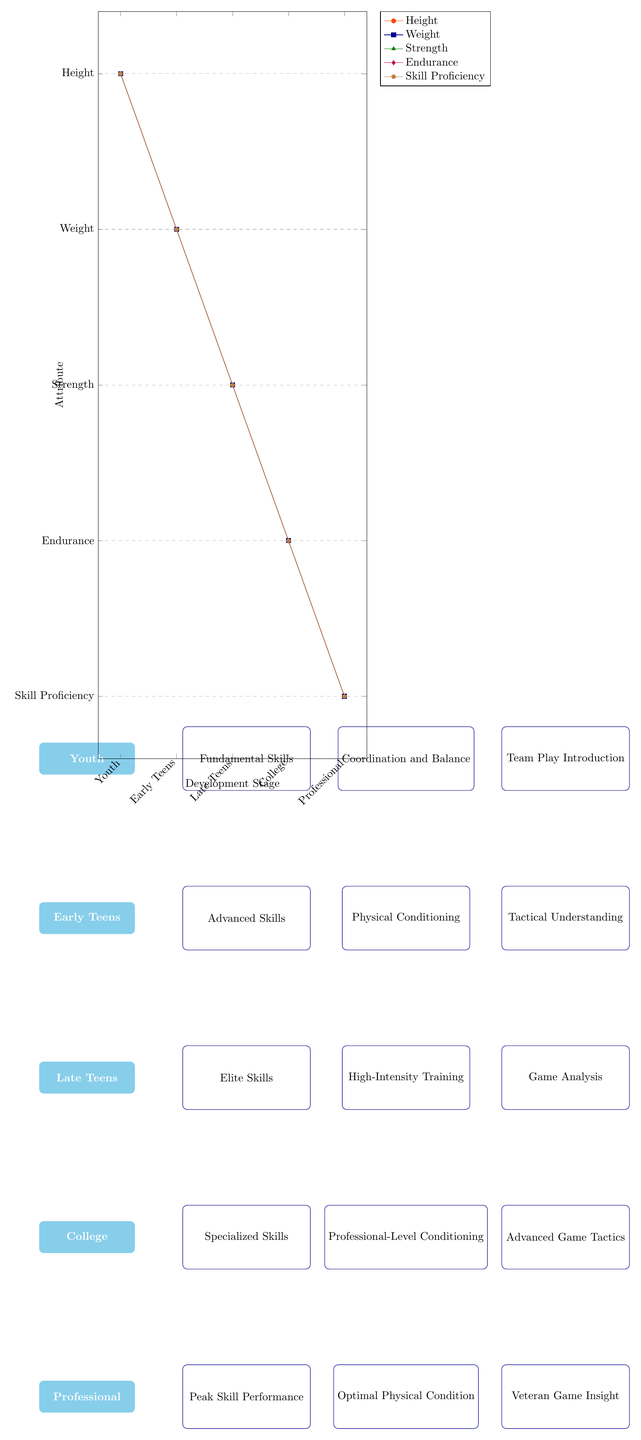What are the stages of development in the diagram? The diagram lists five stages of development: Youth, Early Teens, Late Teens, College, and Professional. These are presented in the timeline diagram format, with each stage shown as a distinct rectangular block.
Answer: Youth, Early Teens, Late Teens, College, Professional How many skill development nodes are present for the Late Teens stage? In the Late Teens stage, there are three skill development nodes: Elite Skills, High-Intensity Training, and Game Analysis. Each of these nodes represents a different aspect of skill development at this stage.
Answer: 3 What does the Height attribute show across the development stages? The Height attribute decreases linearly from the Youth stage (5) to the Professional stage (1), indicating a steady decline in the height measure across stages, represented by the orangered line on the growth chart.
Answer: 5 to 1 Which skill shows the highest proficiency in the Youth stage? The Skill Proficiency attribute starts at the highest level (5) in the Youth stage. This indicates that the foundational skills are prioritized in this early stage, allowing young players to develop essential skills early.
Answer: 5 Which development stage has the lowest Strength value? The Professional stage has the lowest Strength value, which is 1 according to the growth chart. This reveals that while other attributes may peak, strength seems to plateau at the highest competitive level.
Answer: 1 What color represents the Endurance attribute in the growth chart? The Endurance attribute is represented by the color purple in the growth chart, making it distinct and easily identifiable alongside the other attributes tracked in the diagram’s growth patterns.
Answer: Purple Which advanced skill is introduced in the College stage? The College stage introduces Specialized Skills as a key advanced skill, emphasizing the transition to a more focused and competitive development approach during this stage.
Answer: Specialized Skills What pattern is observed in the increase of Weight attribute? The Weight attribute shows a consistent decrease from the Youth stage (5) to the Professional stage (1), indicating that as players mature and focus on conditioning, they may maintain or reduce excess weight.
Answer: Decrease from 5 to 1 